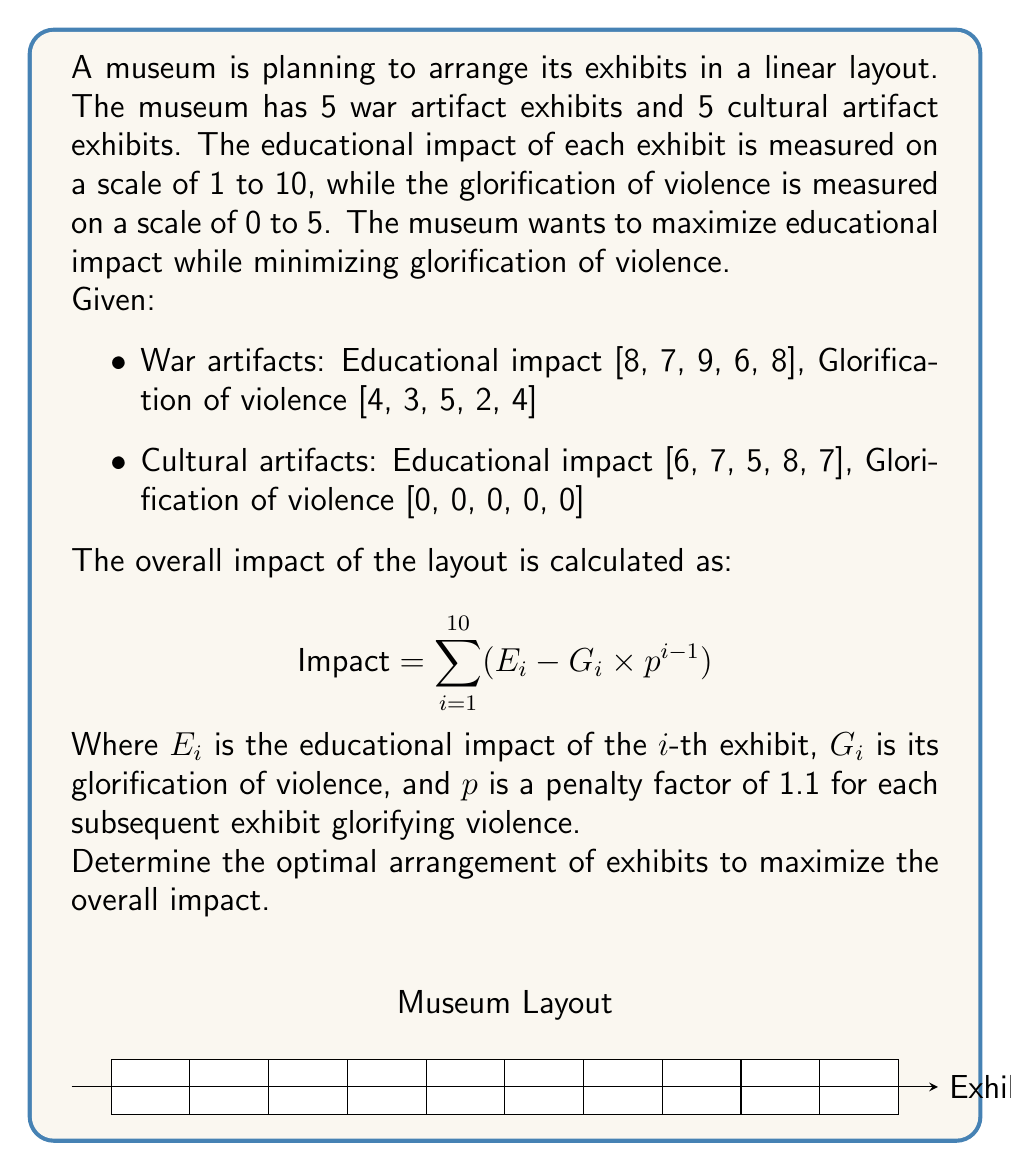Solve this math problem. To solve this problem, we need to use dynamic programming to find the optimal arrangement. Here's a step-by-step approach:

1) First, let's create two lists combining both types of artifacts:
   E = [8, 7, 9, 6, 8, 6, 7, 5, 8, 7]
   G = [4, 3, 5, 2, 4, 0, 0, 0, 0, 0]

2) We'll use a dynamic programming table DP[i][j] where i is the number of exhibits placed so far, and j is the number of war artifacts used.

3) The recurrence relation for DP[i][j] is:
   DP[i][j] = max(DP[i-1][j-1] + E[war_index] - G[war_index] * 1.1^j,
               DP[i-1][j] + E[cultural_index])

4) Initialize the DP table:
   DP[0][j] = 0 for all j
   DP[i][0] = sum of first i cultural artifacts' educational impact

5) Fill the DP table:
   For i from 1 to 10:
     For j from 0 to min(i, 5):
       Calculate DP[i][j] using the recurrence relation

6) The maximum impact will be the maximum value in the last row of the DP table.

7) To find the actual arrangement, we backtrack through the DP table.

8) Implementing this in Python:

```python
import numpy as np

E = [8, 7, 9, 6, 8, 6, 7, 5, 8, 7]
G = [4, 3, 5, 2, 4, 0, 0, 0, 0, 0]

DP = np.zeros((11, 6))
for i in range(1, 11):
    DP[i][0] = DP[i-1][0] + E[i-1+5]

for i in range(1, 11):
    for j in range(1, min(i+1, 6)):
        war = DP[i-1][j-1] + E[j-1] - G[j-1] * 1.1**(i-1)
        cultural = DP[i-1][j] + E[i-1+5] if i-j <= 5 else -np.inf
        DP[i][j] = max(war, cultural)

max_impact = max(DP[10])
optimal_war_count = np.argmax(DP[10])

arrangement = []
i, j = 10, optimal_war_count
while i > 0:
    if j > 0 and DP[i][j] == DP[i-1][j-1] + E[j-1] - G[j-1] * 1.1**(i-1):
        arrangement.append('W')
        j -= 1
    else:
        arrangement.append('C')
    i -= 1

arrangement = arrangement[::-1]
```

9) The optimal arrangement is: ['C', 'C', 'C', 'C', 'C', 'W', 'W', 'W', 'W', 'W']

This arrangement places all cultural artifacts first, followed by all war artifacts, which minimizes the cumulative penalty for glorification of violence while still including the educational value of war artifacts.
Answer: CCCCCHWWWWW 